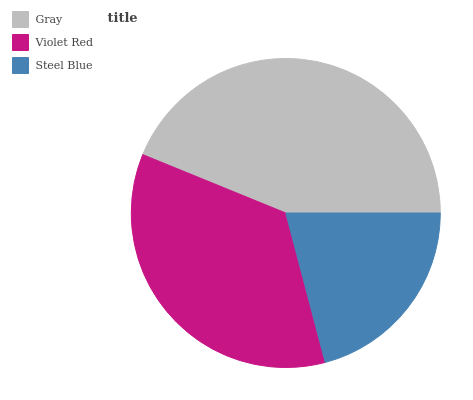Is Steel Blue the minimum?
Answer yes or no. Yes. Is Gray the maximum?
Answer yes or no. Yes. Is Violet Red the minimum?
Answer yes or no. No. Is Violet Red the maximum?
Answer yes or no. No. Is Gray greater than Violet Red?
Answer yes or no. Yes. Is Violet Red less than Gray?
Answer yes or no. Yes. Is Violet Red greater than Gray?
Answer yes or no. No. Is Gray less than Violet Red?
Answer yes or no. No. Is Violet Red the high median?
Answer yes or no. Yes. Is Violet Red the low median?
Answer yes or no. Yes. Is Steel Blue the high median?
Answer yes or no. No. Is Gray the low median?
Answer yes or no. No. 